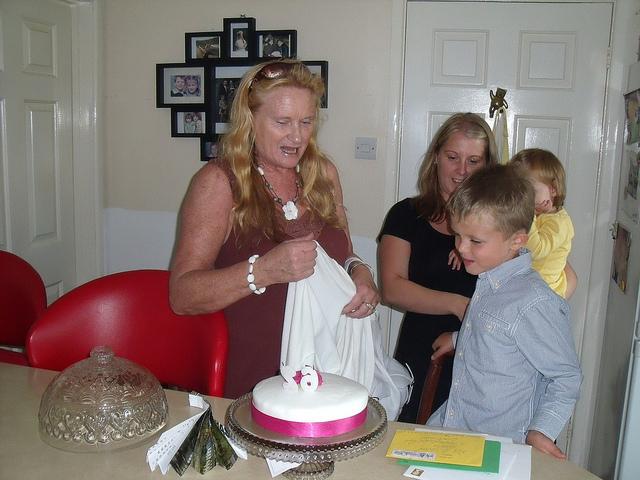Which birthday is being celebrated?
Concise answer only. 62. Do you think that cake is for the child or adult?
Short answer required. Adult. Is there a ribbon in the image?
Short answer required. Yes. How old is this boy?
Give a very brief answer. 6. 